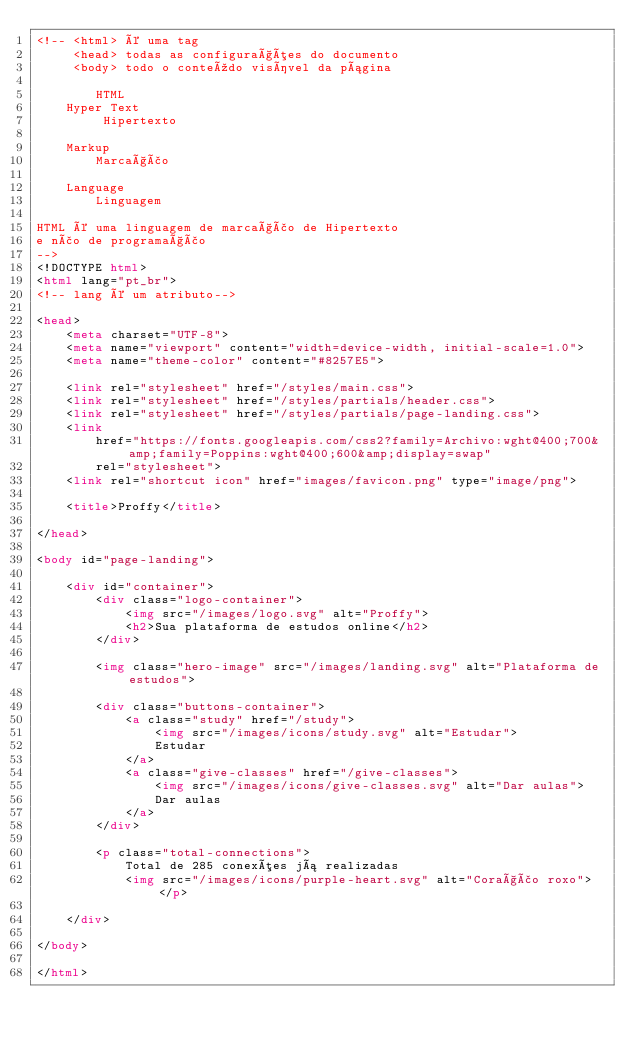<code> <loc_0><loc_0><loc_500><loc_500><_HTML_><!-- <html> é uma tag
     <head> todas as configurações do documento
     <body> todo o conteúdo visível da página

        HTML
    Hyper Text
         Hipertexto

    Markup
        Marcação

    Language
        Linguagem

HTML é uma linguagem de marcação de Hipertexto
e não de programação
-->
<!DOCTYPE html>
<html lang="pt_br">
<!-- lang é um atributo-->

<head>
    <meta charset="UTF-8">
    <meta name="viewport" content="width=device-width, initial-scale=1.0">
    <meta name="theme-color" content="#8257E5">

    <link rel="stylesheet" href="/styles/main.css">
    <link rel="stylesheet" href="/styles/partials/header.css">
    <link rel="stylesheet" href="/styles/partials/page-landing.css">
    <link
        href="https://fonts.googleapis.com/css2?family=Archivo:wght@400;700&amp;family=Poppins:wght@400;600&amp;display=swap"
        rel="stylesheet">
    <link rel="shortcut icon" href="images/favicon.png" type="image/png">

    <title>Proffy</title>

</head>

<body id="page-landing">

    <div id="container">
        <div class="logo-container">
            <img src="/images/logo.svg" alt="Proffy">
            <h2>Sua plataforma de estudos online</h2>
        </div>

        <img class="hero-image" src="/images/landing.svg" alt="Plataforma de estudos">

        <div class="buttons-container">
            <a class="study" href="/study">
                <img src="/images/icons/study.svg" alt="Estudar">
                Estudar
            </a>
            <a class="give-classes" href="/give-classes">
                <img src="/images/icons/give-classes.svg" alt="Dar aulas">
                Dar aulas
            </a>
        </div>

        <p class="total-connections">
            Total de 285 conexões já realizadas
            <img src="/images/icons/purple-heart.svg" alt="Coração roxo"> </p>

    </div>

</body>

</html></code> 